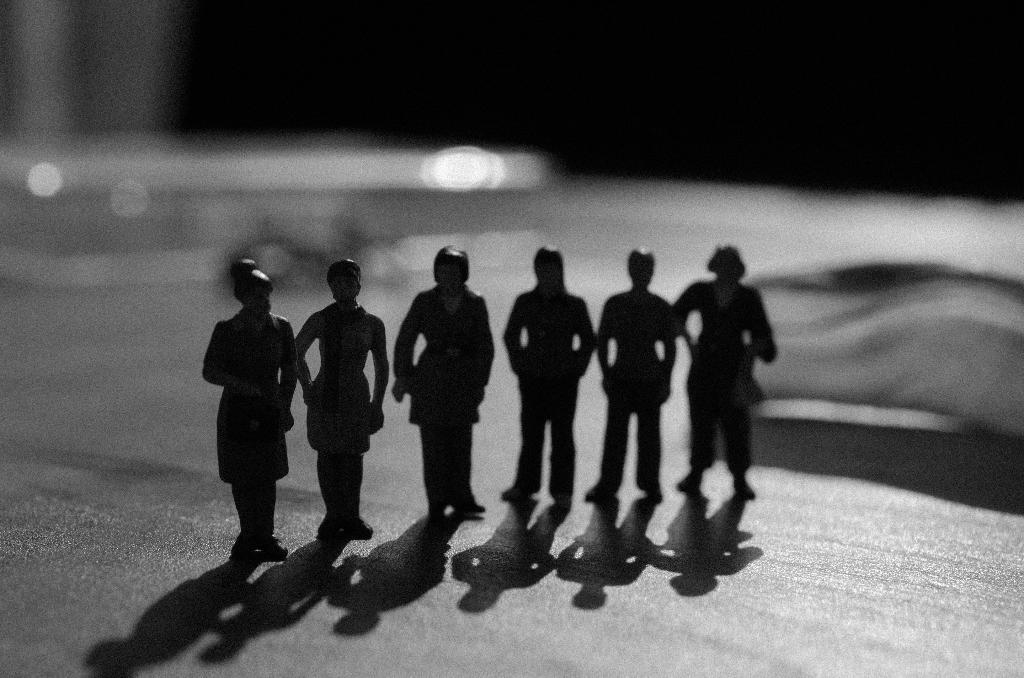What is the color scheme of the image? The image is black and white. How many toys can be seen in the image? There are six small toys in the image. Where are the toys located in the image? The toys are standing on the floor. How many spiders are crawling on the toys in the image? There are no spiders present in the image; it only features six small toys standing on the floor. What is the best way to reach the yard from the location of the image? The provided facts do not give any information about the location or the presence of a yard, so it is impossible to determine the best way to reach it from the image. 